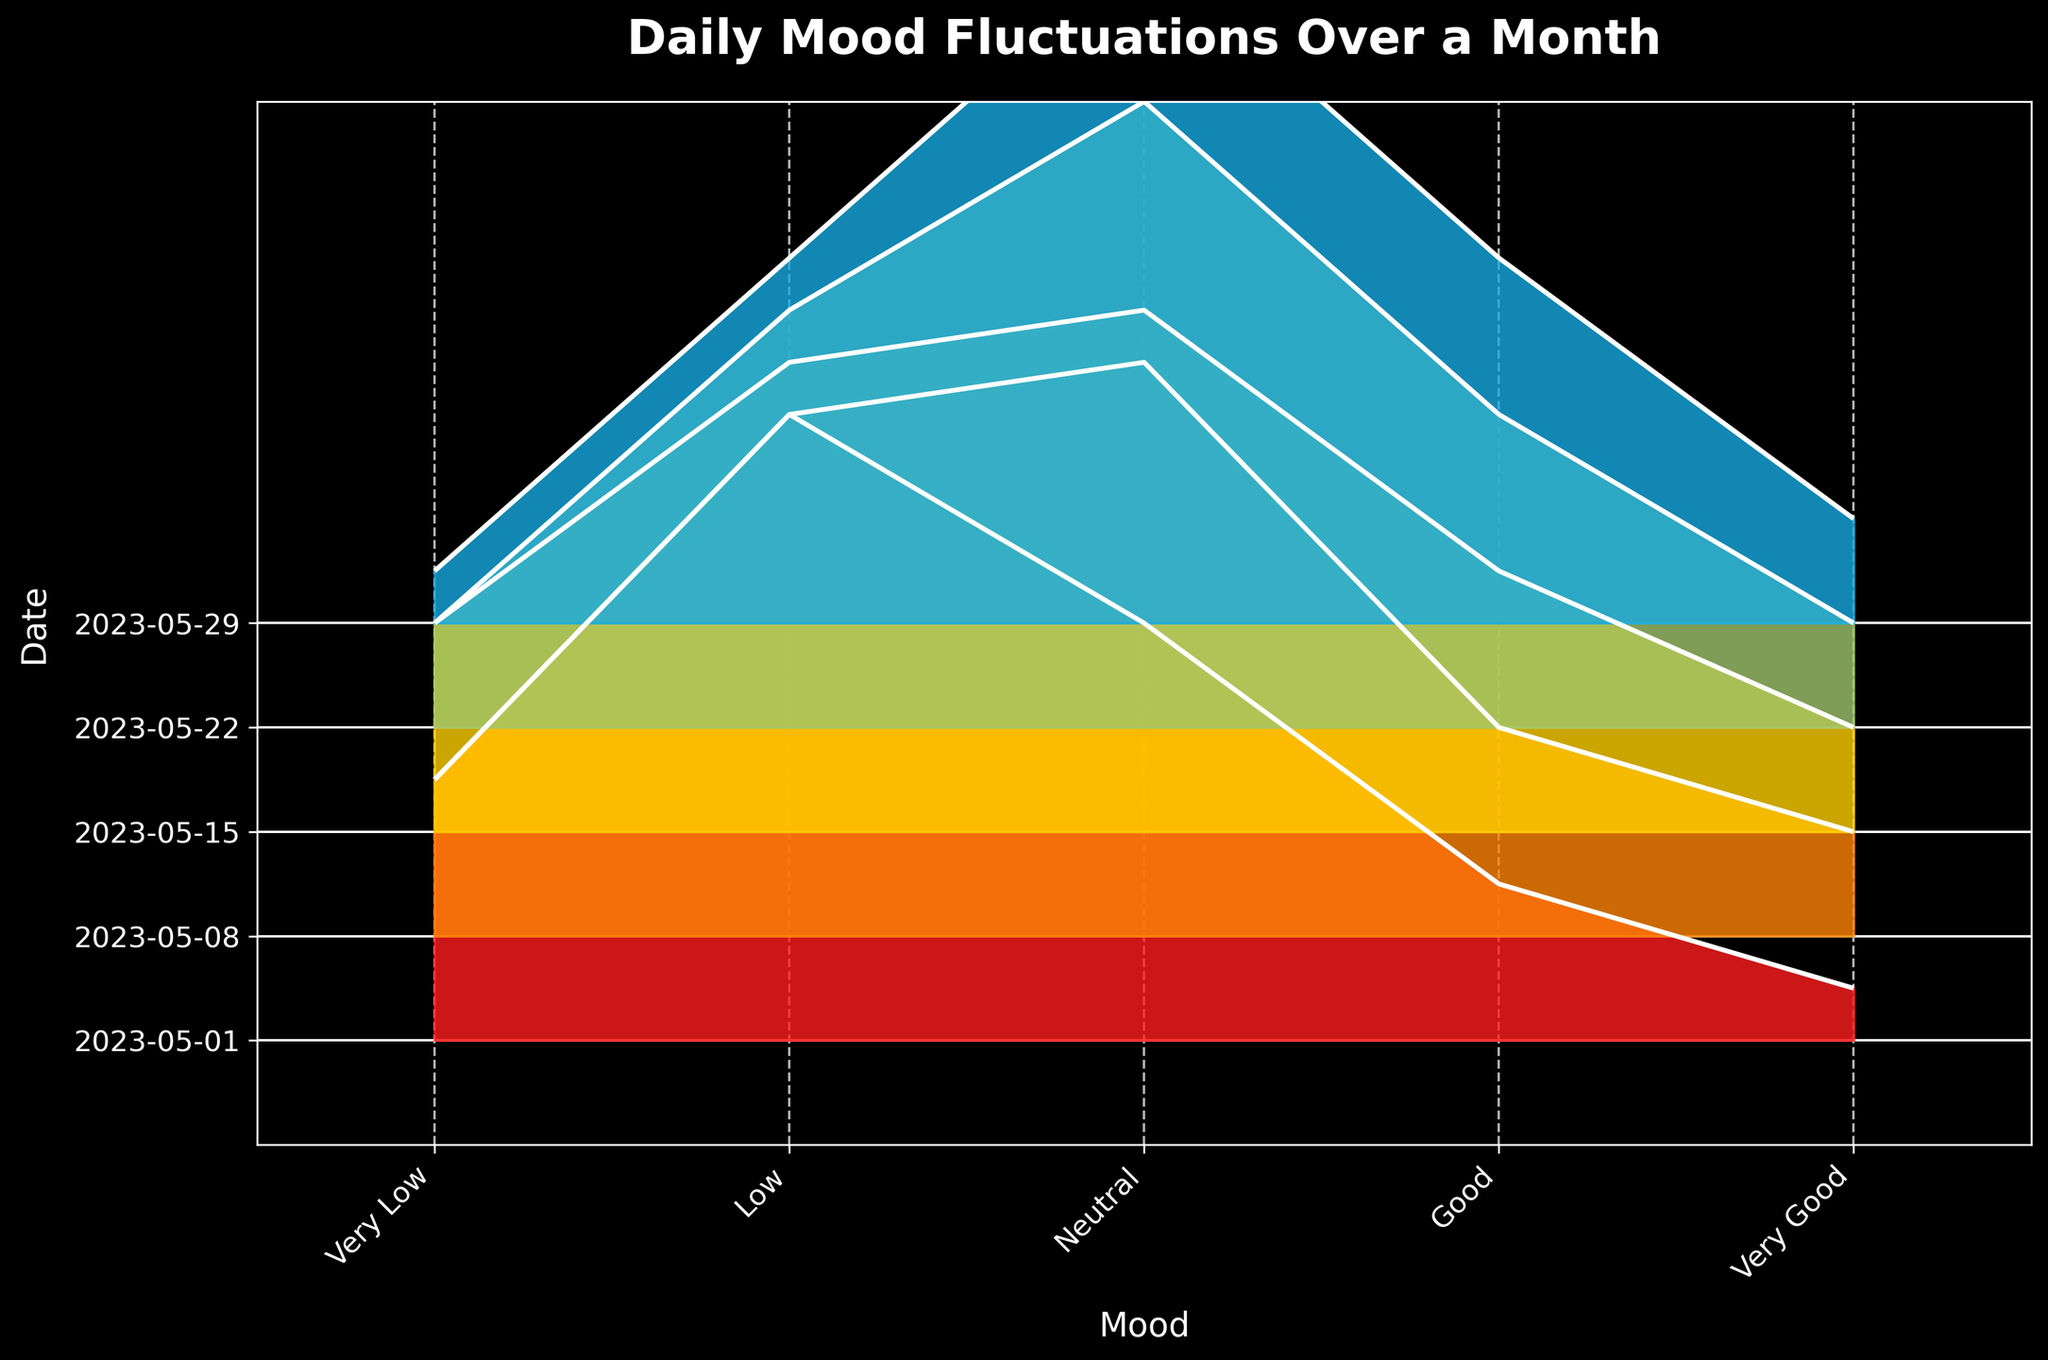What's the title of the figure? Look at the top center part of the figure where titles are usually placed.
Answer: Daily Mood Fluctuations Over a Month Which mood was reported the most frequently on May 1st? Look at the height of each mood category for May 1st. The highest frequency bar indicates the most reported mood.
Answer: Low How does the frequency of "Very Good" mood on May 15th compare to May 29th? Compare the heights of the "Very Good" bars for May 15th and May 29th.
Answer: Same What is the sum of all moods' frequencies on May 22nd? Add up the heights of all moods for May 22nd: 2 (Very Low) + 8 (Low) + 12 (Neutral) + 6 (Good) + 2 (Very Good).
Answer: 30 On which date was the "Neutral" mood reported the most? Look for the tallest bar under the "Neutral" mood category across all dates.
Answer: May 29th Which date has the lowest frequency of "Very Low" mood? Compare the height of the "Very Low" bars across all dates.
Answer: May 29th Is there any date where the "Good" mood frequency is equal to the "Very Good" mood frequency? Compare the heights of "Good" and "Very Good" bars for all dates, looking for equal heights.
Answer: May 29th What's the general trend for the "Very Low" mood frequency over the month? Look at the heights of the "Very Low" mood bars over time and observe the trend.
Answer: Decreasing 